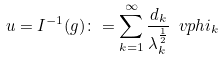<formula> <loc_0><loc_0><loc_500><loc_500>u = I ^ { - 1 } ( g ) \colon = \sum _ { k = 1 } ^ { \infty } \frac { d _ { k } } { \lambda _ { k } ^ { \frac { 1 } { 2 } } } \ v p h i _ { k }</formula> 